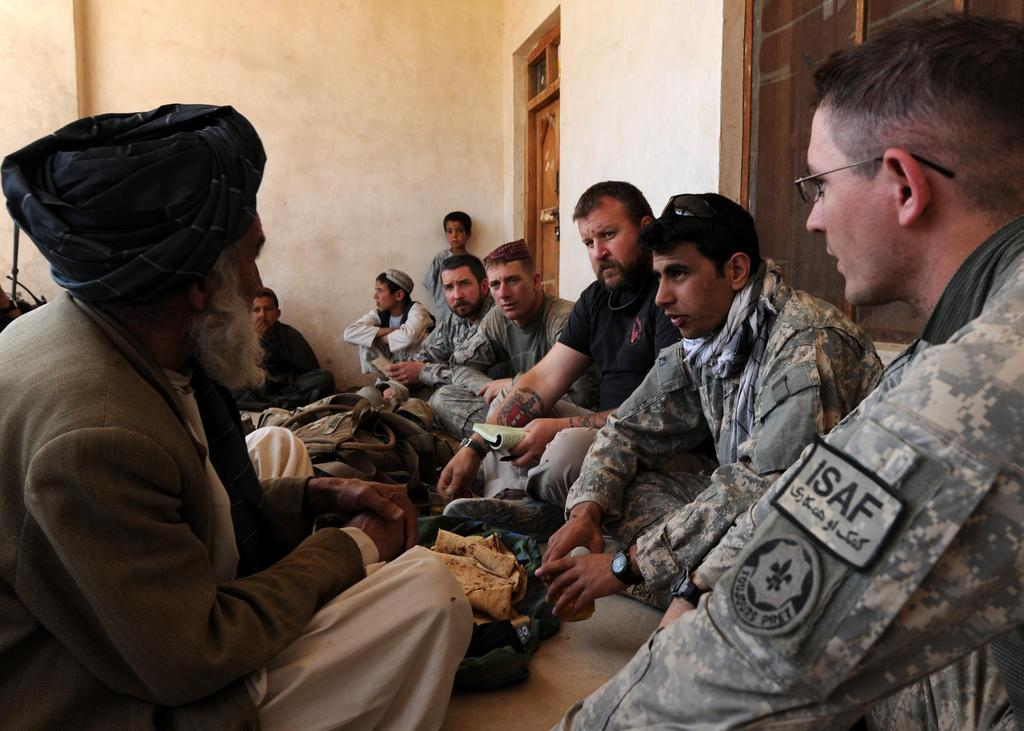How many people are in the image? There is a group of people in the image. What are some of the people in the image doing? Some people are sitting on the floor. What can be seen in the background of the image? There is a wall, a door, and a window in the background of the image. What objects are present in the image? There are bags and other objects visible. What type of wood can be seen in the cemetery in the image? There is no cemetery present in the image, and therefore no wood can be observed. 